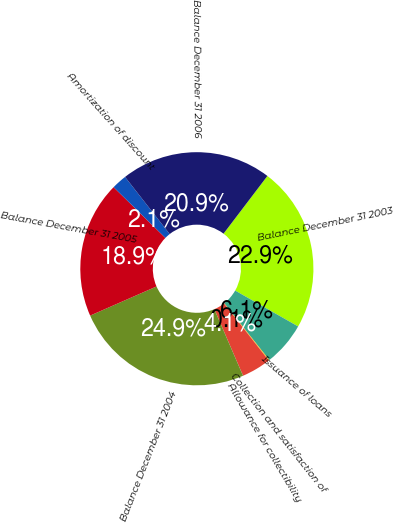Convert chart. <chart><loc_0><loc_0><loc_500><loc_500><pie_chart><fcel>Balance December 31 2003<fcel>Issuance of loans<fcel>Collection and satisfaction of<fcel>Allowance for collectibility<fcel>Balance December 31 2004<fcel>Balance December 31 2005<fcel>Amortization of discount<fcel>Balance December 31 2006<nl><fcel>22.9%<fcel>6.08%<fcel>0.1%<fcel>4.09%<fcel>24.9%<fcel>18.92%<fcel>2.1%<fcel>20.91%<nl></chart> 